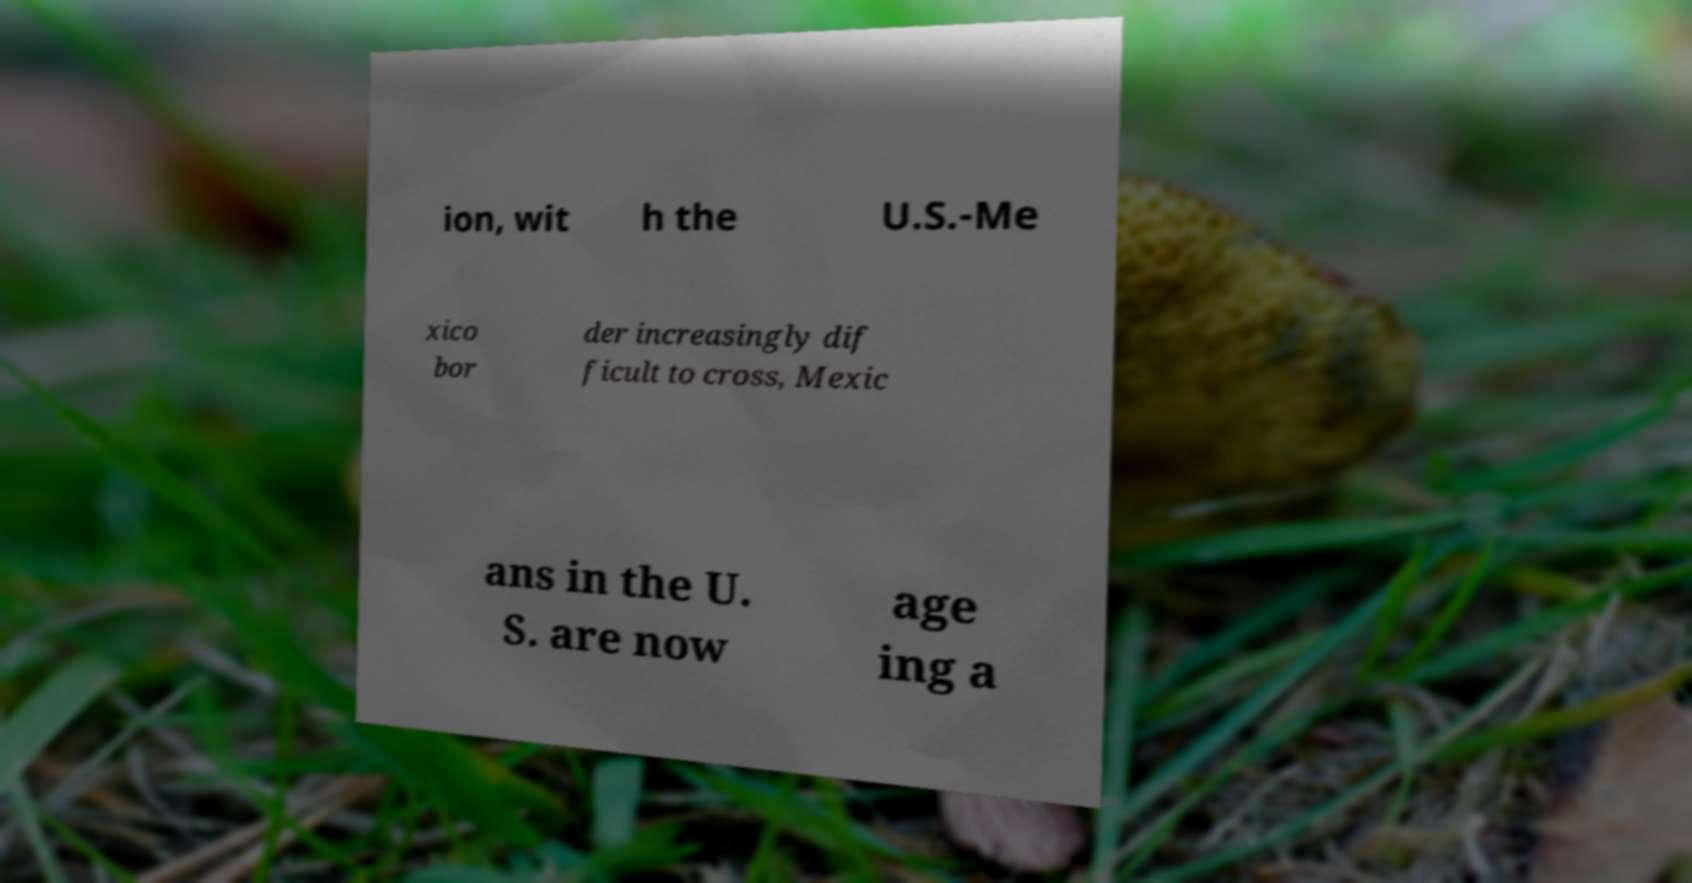Please identify and transcribe the text found in this image. ion, wit h the U.S.-Me xico bor der increasingly dif ficult to cross, Mexic ans in the U. S. are now age ing a 